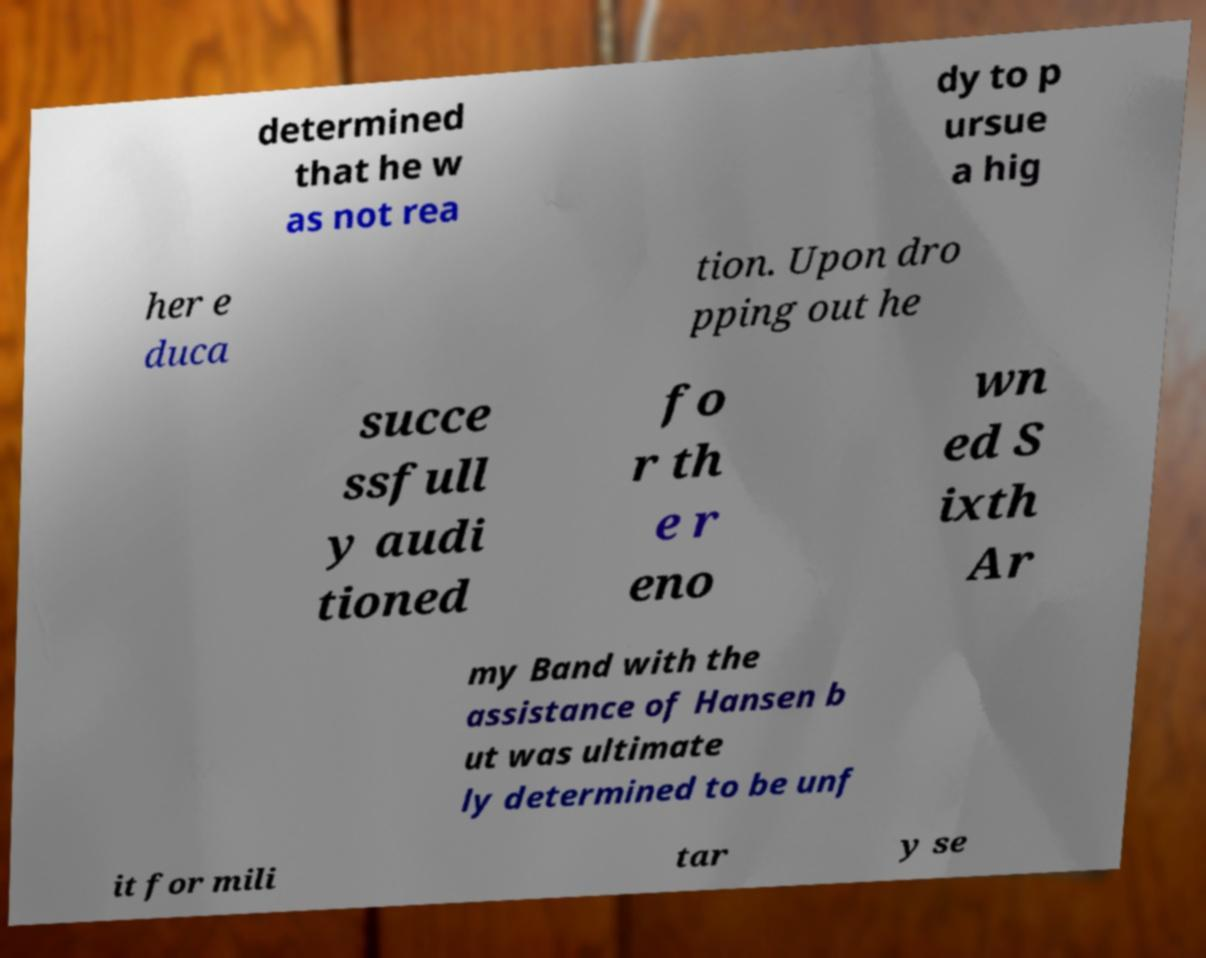Can you accurately transcribe the text from the provided image for me? determined that he w as not rea dy to p ursue a hig her e duca tion. Upon dro pping out he succe ssfull y audi tioned fo r th e r eno wn ed S ixth Ar my Band with the assistance of Hansen b ut was ultimate ly determined to be unf it for mili tar y se 